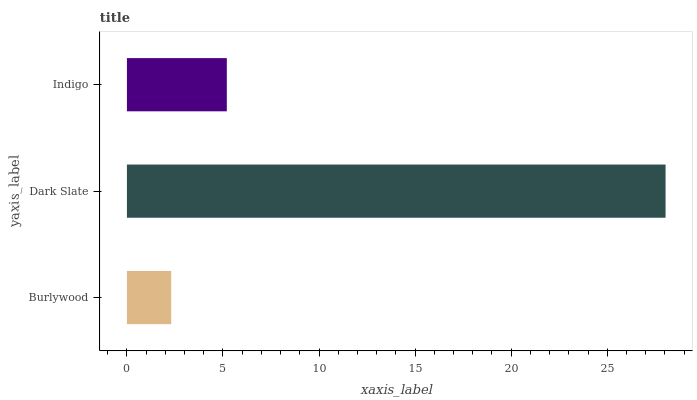Is Burlywood the minimum?
Answer yes or no. Yes. Is Dark Slate the maximum?
Answer yes or no. Yes. Is Indigo the minimum?
Answer yes or no. No. Is Indigo the maximum?
Answer yes or no. No. Is Dark Slate greater than Indigo?
Answer yes or no. Yes. Is Indigo less than Dark Slate?
Answer yes or no. Yes. Is Indigo greater than Dark Slate?
Answer yes or no. No. Is Dark Slate less than Indigo?
Answer yes or no. No. Is Indigo the high median?
Answer yes or no. Yes. Is Indigo the low median?
Answer yes or no. Yes. Is Dark Slate the high median?
Answer yes or no. No. Is Dark Slate the low median?
Answer yes or no. No. 